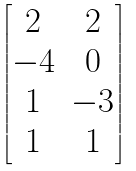<formula> <loc_0><loc_0><loc_500><loc_500>\begin{bmatrix} 2 & 2 \\ - 4 & 0 \\ 1 & - 3 \\ 1 & 1 \end{bmatrix}</formula> 